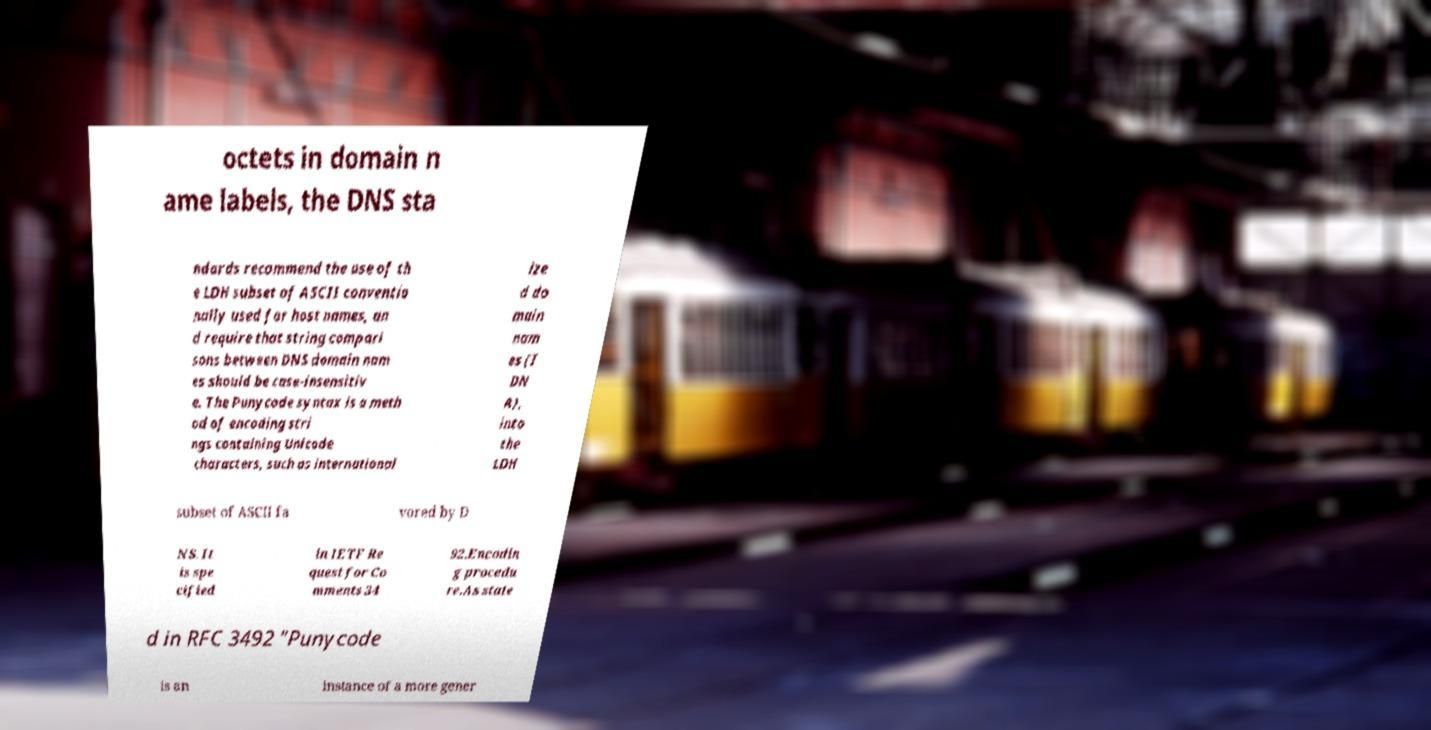I need the written content from this picture converted into text. Can you do that? octets in domain n ame labels, the DNS sta ndards recommend the use of th e LDH subset of ASCII conventio nally used for host names, an d require that string compari sons between DNS domain nam es should be case-insensitiv e. The Punycode syntax is a meth od of encoding stri ngs containing Unicode characters, such as international ize d do main nam es (I DN A), into the LDH subset of ASCII fa vored by D NS. It is spe cified in IETF Re quest for Co mments 34 92.Encodin g procedu re.As state d in RFC 3492 "Punycode is an instance of a more gener 